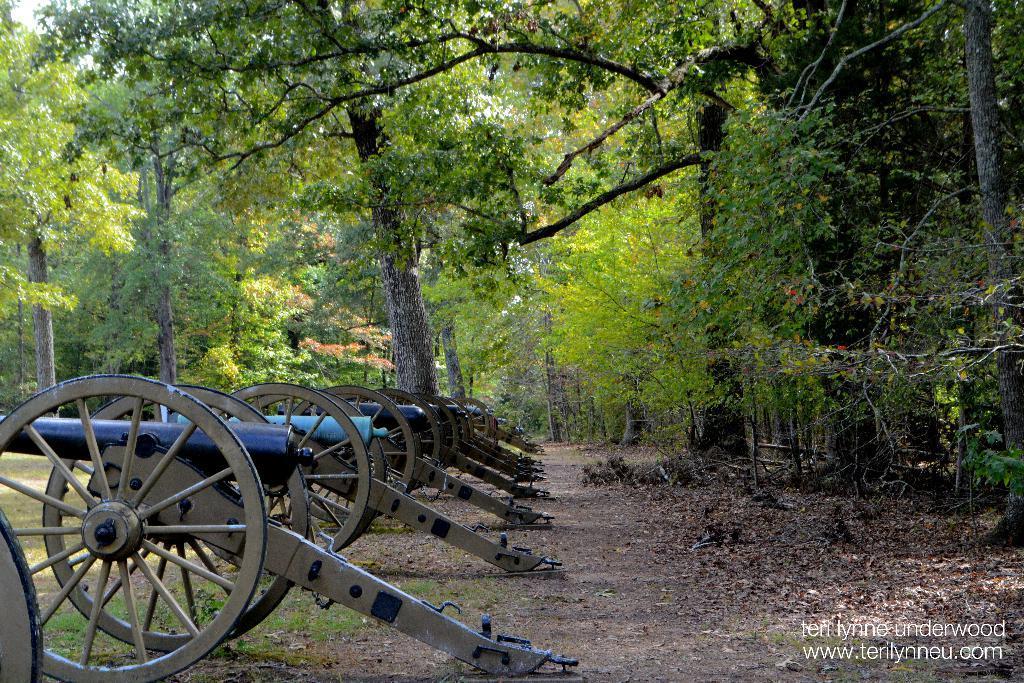Please provide a concise description of this image. In this image we can see carts on the ground. On the right side of the image we can see many trees and leaves. On the left side of the image we can see trees and carts. In the background we can see trees and sky. 